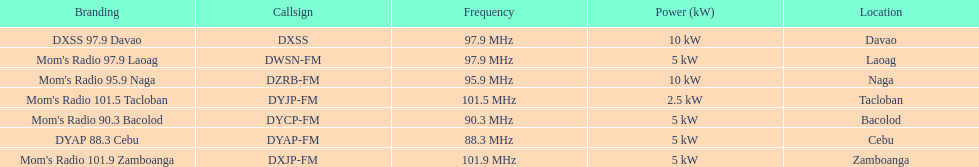What is the only radio station with a frequency below 90 mhz? DYAP 88.3 Cebu. 